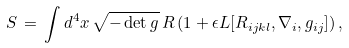Convert formula to latex. <formula><loc_0><loc_0><loc_500><loc_500>S \, = \, \int d ^ { 4 } x \, \sqrt { - \det g } \, R \, ( 1 + \epsilon L [ R _ { i j k l } , \nabla _ { i } , g _ { i j } ] ) \, ,</formula> 